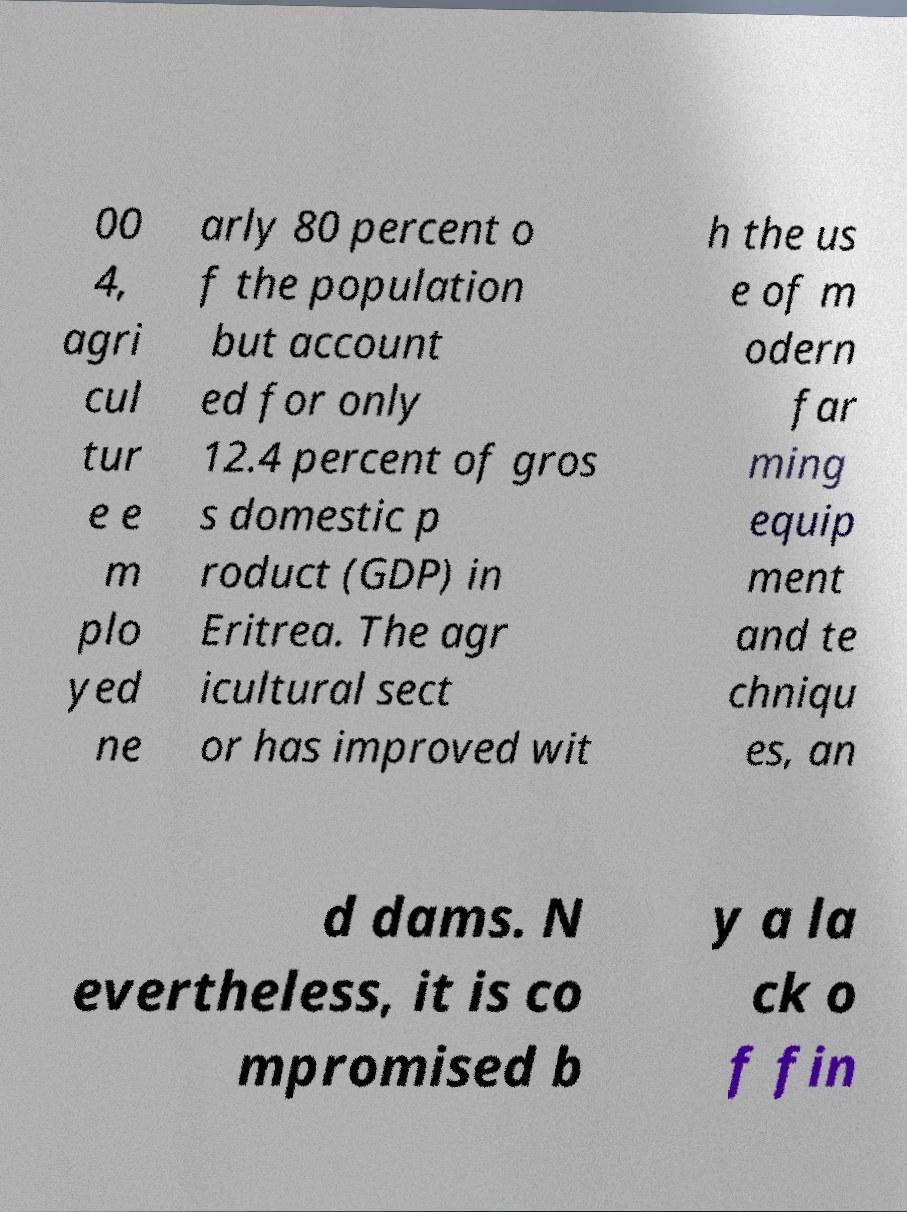I need the written content from this picture converted into text. Can you do that? 00 4, agri cul tur e e m plo yed ne arly 80 percent o f the population but account ed for only 12.4 percent of gros s domestic p roduct (GDP) in Eritrea. The agr icultural sect or has improved wit h the us e of m odern far ming equip ment and te chniqu es, an d dams. N evertheless, it is co mpromised b y a la ck o f fin 